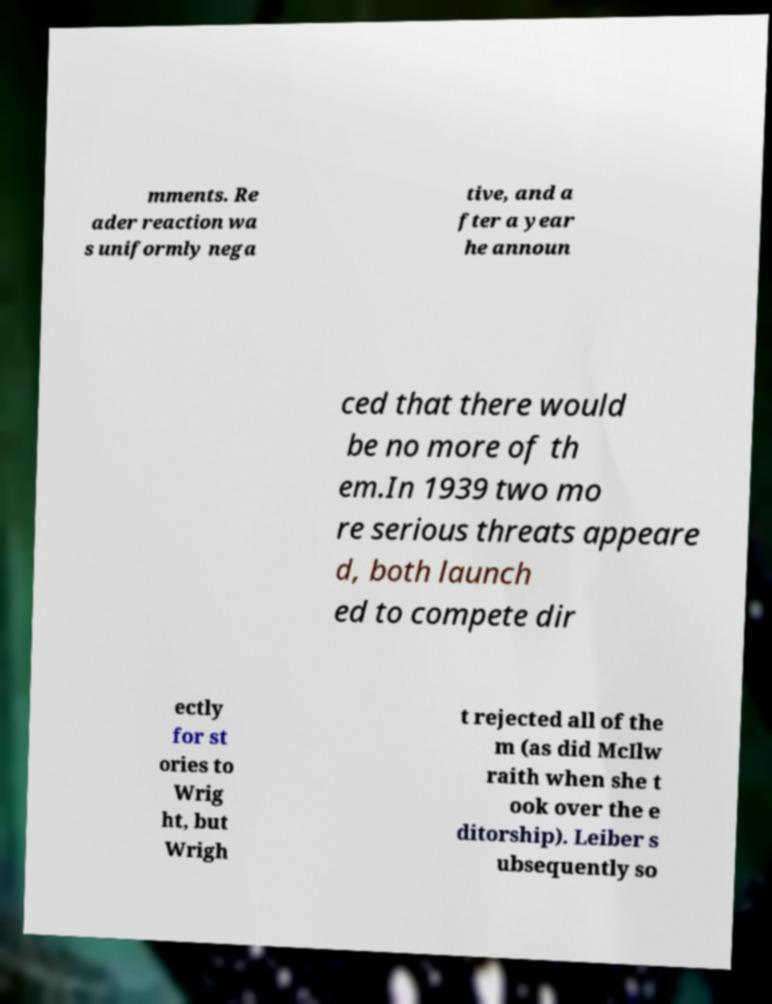Please identify and transcribe the text found in this image. mments. Re ader reaction wa s uniformly nega tive, and a fter a year he announ ced that there would be no more of th em.In 1939 two mo re serious threats appeare d, both launch ed to compete dir ectly for st ories to Wrig ht, but Wrigh t rejected all of the m (as did McIlw raith when she t ook over the e ditorship). Leiber s ubsequently so 